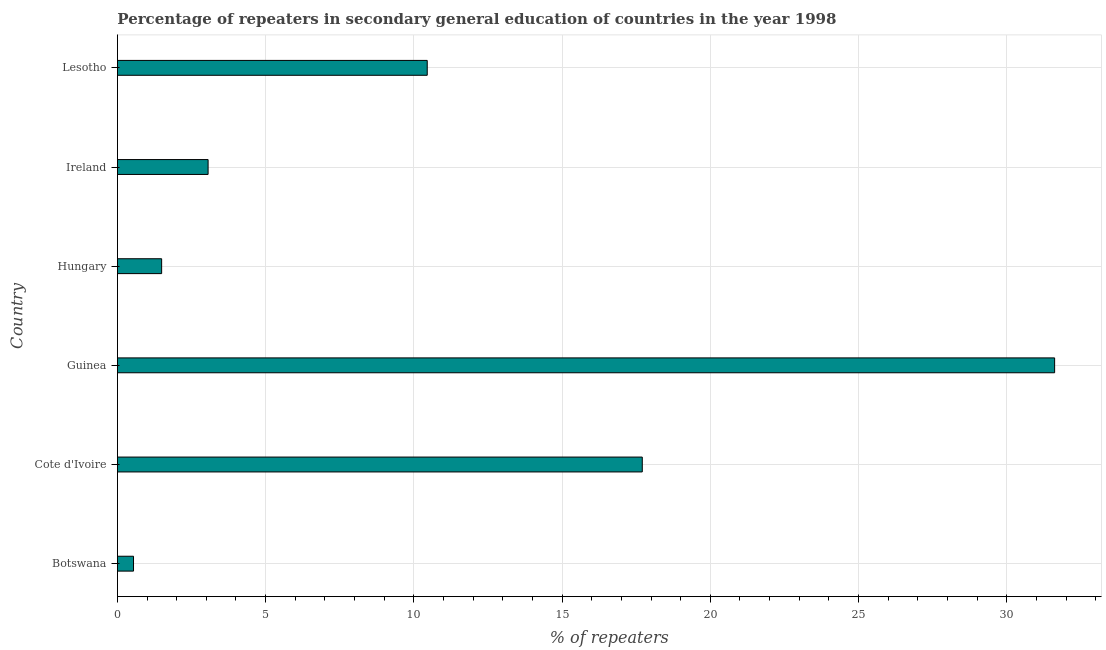What is the title of the graph?
Your answer should be compact. Percentage of repeaters in secondary general education of countries in the year 1998. What is the label or title of the X-axis?
Offer a terse response. % of repeaters. What is the percentage of repeaters in Botswana?
Keep it short and to the point. 0.54. Across all countries, what is the maximum percentage of repeaters?
Provide a short and direct response. 31.62. Across all countries, what is the minimum percentage of repeaters?
Your response must be concise. 0.54. In which country was the percentage of repeaters maximum?
Ensure brevity in your answer.  Guinea. In which country was the percentage of repeaters minimum?
Offer a terse response. Botswana. What is the sum of the percentage of repeaters?
Provide a short and direct response. 64.87. What is the difference between the percentage of repeaters in Hungary and Ireland?
Ensure brevity in your answer.  -1.57. What is the average percentage of repeaters per country?
Make the answer very short. 10.81. What is the median percentage of repeaters?
Your answer should be compact. 6.76. What is the ratio of the percentage of repeaters in Botswana to that in Ireland?
Your answer should be compact. 0.18. Is the percentage of repeaters in Cote d'Ivoire less than that in Lesotho?
Your answer should be compact. No. What is the difference between the highest and the second highest percentage of repeaters?
Your response must be concise. 13.91. Is the sum of the percentage of repeaters in Guinea and Hungary greater than the maximum percentage of repeaters across all countries?
Your answer should be very brief. Yes. What is the difference between the highest and the lowest percentage of repeaters?
Your answer should be compact. 31.07. In how many countries, is the percentage of repeaters greater than the average percentage of repeaters taken over all countries?
Provide a succinct answer. 2. How many countries are there in the graph?
Give a very brief answer. 6. Are the values on the major ticks of X-axis written in scientific E-notation?
Give a very brief answer. No. What is the % of repeaters of Botswana?
Your response must be concise. 0.54. What is the % of repeaters in Cote d'Ivoire?
Provide a succinct answer. 17.71. What is the % of repeaters in Guinea?
Offer a very short reply. 31.62. What is the % of repeaters in Hungary?
Your answer should be compact. 1.49. What is the % of repeaters of Ireland?
Your response must be concise. 3.06. What is the % of repeaters of Lesotho?
Give a very brief answer. 10.45. What is the difference between the % of repeaters in Botswana and Cote d'Ivoire?
Offer a very short reply. -17.16. What is the difference between the % of repeaters in Botswana and Guinea?
Provide a succinct answer. -31.07. What is the difference between the % of repeaters in Botswana and Hungary?
Offer a very short reply. -0.95. What is the difference between the % of repeaters in Botswana and Ireland?
Offer a very short reply. -2.52. What is the difference between the % of repeaters in Botswana and Lesotho?
Provide a short and direct response. -9.91. What is the difference between the % of repeaters in Cote d'Ivoire and Guinea?
Provide a short and direct response. -13.91. What is the difference between the % of repeaters in Cote d'Ivoire and Hungary?
Make the answer very short. 16.21. What is the difference between the % of repeaters in Cote d'Ivoire and Ireland?
Offer a very short reply. 14.65. What is the difference between the % of repeaters in Cote d'Ivoire and Lesotho?
Offer a terse response. 7.25. What is the difference between the % of repeaters in Guinea and Hungary?
Your response must be concise. 30.12. What is the difference between the % of repeaters in Guinea and Ireland?
Keep it short and to the point. 28.56. What is the difference between the % of repeaters in Guinea and Lesotho?
Make the answer very short. 21.16. What is the difference between the % of repeaters in Hungary and Ireland?
Offer a very short reply. -1.57. What is the difference between the % of repeaters in Hungary and Lesotho?
Keep it short and to the point. -8.96. What is the difference between the % of repeaters in Ireland and Lesotho?
Offer a very short reply. -7.39. What is the ratio of the % of repeaters in Botswana to that in Cote d'Ivoire?
Ensure brevity in your answer.  0.03. What is the ratio of the % of repeaters in Botswana to that in Guinea?
Offer a very short reply. 0.02. What is the ratio of the % of repeaters in Botswana to that in Hungary?
Keep it short and to the point. 0.36. What is the ratio of the % of repeaters in Botswana to that in Ireland?
Keep it short and to the point. 0.18. What is the ratio of the % of repeaters in Botswana to that in Lesotho?
Keep it short and to the point. 0.05. What is the ratio of the % of repeaters in Cote d'Ivoire to that in Guinea?
Keep it short and to the point. 0.56. What is the ratio of the % of repeaters in Cote d'Ivoire to that in Hungary?
Give a very brief answer. 11.87. What is the ratio of the % of repeaters in Cote d'Ivoire to that in Ireland?
Offer a terse response. 5.79. What is the ratio of the % of repeaters in Cote d'Ivoire to that in Lesotho?
Your response must be concise. 1.69. What is the ratio of the % of repeaters in Guinea to that in Hungary?
Provide a succinct answer. 21.19. What is the ratio of the % of repeaters in Guinea to that in Ireland?
Your response must be concise. 10.33. What is the ratio of the % of repeaters in Guinea to that in Lesotho?
Make the answer very short. 3.02. What is the ratio of the % of repeaters in Hungary to that in Ireland?
Your answer should be compact. 0.49. What is the ratio of the % of repeaters in Hungary to that in Lesotho?
Provide a short and direct response. 0.14. What is the ratio of the % of repeaters in Ireland to that in Lesotho?
Keep it short and to the point. 0.29. 